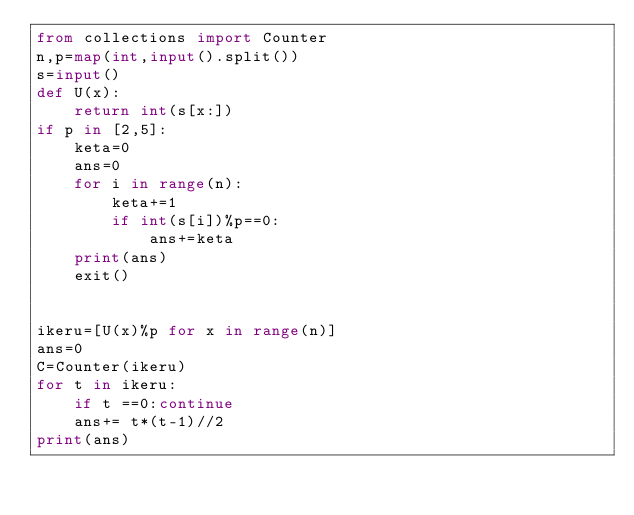<code> <loc_0><loc_0><loc_500><loc_500><_Python_>from collections import Counter
n,p=map(int,input().split())
s=input()
def U(x):
    return int(s[x:])
if p in [2,5]:
    keta=0
    ans=0
    for i in range(n):
        keta+=1
        if int(s[i])%p==0:
            ans+=keta
    print(ans)
    exit()


ikeru=[U(x)%p for x in range(n)]
ans=0
C=Counter(ikeru)
for t in ikeru:
    if t ==0:continue
    ans+= t*(t-1)//2
print(ans)</code> 